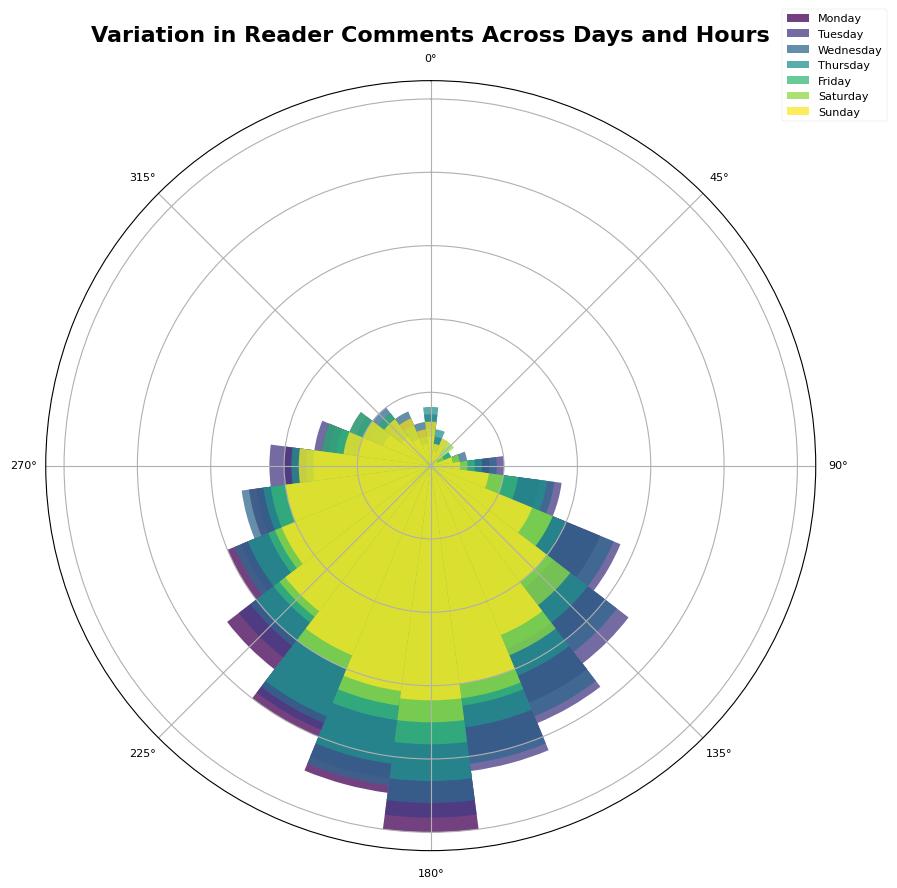what day has the highest comments around noon (12 PM) and how many comments were there? First, locate the part of the chart corresponding to noon (12 PM). Then identify the highest bar in this position, which corresponds to the peak engagement on that day.
Answer: Monday and 50 comments which day sees the least comments in the early morning (3 AM)? Check the bars around each day at the 3 AM line, and identify the shortest bar.
Answer: Monday on which day do comments peak earlier in the day, on Wednesday or Thursday? Compare the peak comment times on Wednesday and Thursday, find the earliest peak.
Answer: Wednesday how many more comments were there at 8 AM on Tuesday compared to Sunday? Locate 8 AM on the chart for both Tuesday and Sunday, and compare the heights of the bars. Subtract the value for Sunday from the value for Tuesday. 28 - 15 = 13
Answer: 13 is the comment activity higher in the evenings (6 PM - 11 PM) or mornings (6 AM - 11 AM) on Sundays? Sum the bar heights for the evening and morning periods on Sunday and compare. Evening: (18 + 12 + 10 + 8 + 7) = 55, Morning: (8 + 15 + 20 + 25 + 30) = 98
Answer: Mornings which day shows a steeper rise in comments from 6 AM to 12 PM, Monday or Friday? Compare the difference in comments from 6 AM to 12 PM for both days: Monday: 50 - 8 = 42, Friday: 38 - 6 = 32
Answer: Monday what time on Wednesday has almost the same number of comments as 9 AM on Monday? Find the bar height for 9 AM Monday, which is 30. Find a similar height around 9 AM on Wednesday.
Answer: 9 AM how many total comments were made during the peak times across all days? Sum up the number of comments at the peak time of each day: 50 (Monday) + 48 (Tuesday) + 46 (Wednesday) + 43 (Thursday) + 38 (Friday) + 35 (Saturday) + 32 (Sunday) = 292
Answer: 292 